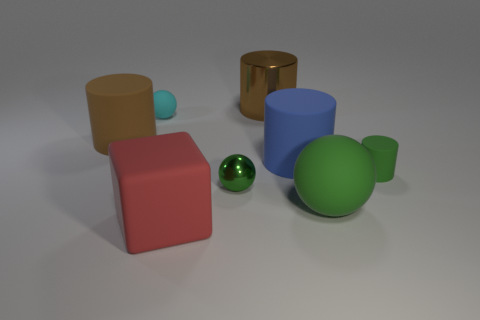Subtract all small metallic balls. How many balls are left? 2 Add 1 green cylinders. How many objects exist? 9 Subtract all red cylinders. How many green balls are left? 2 Subtract all cyan spheres. How many spheres are left? 2 Subtract 1 cylinders. How many cylinders are left? 3 Subtract 1 blue cylinders. How many objects are left? 7 Subtract all spheres. How many objects are left? 5 Subtract all brown spheres. Subtract all brown cubes. How many spheres are left? 3 Subtract all tiny yellow metallic cylinders. Subtract all red cubes. How many objects are left? 7 Add 3 cyan objects. How many cyan objects are left? 4 